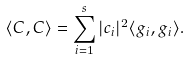Convert formula to latex. <formula><loc_0><loc_0><loc_500><loc_500>\langle C , C \rangle = \sum _ { i = 1 } ^ { s } | c _ { i } | ^ { 2 } \langle g _ { i } , g _ { i } \rangle .</formula> 